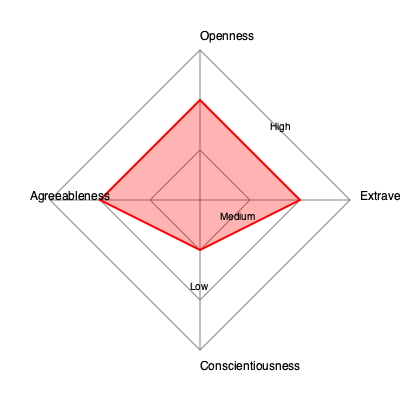Based on the radar chart depicting the distribution of personality traits among successful rehabilitation program participants, which trait appears to be the least pronounced, and what implications might this have for tailoring future interventions in rehabilitation programs? To answer this question, we need to analyze the radar chart and understand its implications:

1. Interpret the radar chart:
   - The chart shows four personality traits: Extraversion, Openness, Agreeableness, and Conscientiousness.
   - The red polygon represents the average scores for successful participants.
   - The further the polygon extends in a direction, the more pronounced that trait is.

2. Identify the least pronounced trait:
   - Agreeableness extends the least from the center, indicating it's the least pronounced trait.

3. Consider the implications for future interventions:
   - Lower Agreeableness suggests participants may be less cooperative or empathetic.
   - Interventions could focus on improving interpersonal skills and empathy.
   - Programs might incorporate more team-based activities to foster cooperation.
   - Conflict resolution training could be beneficial.
   - Individual counseling might address trust issues or social difficulties.

4. Reflect on the other traits:
   - Higher Extraversion and Openness suggest participants may respond well to social and novel experiences.
   - Moderate to high Conscientiousness indicates potential for goal-setting and self-discipline.

5. Tailor interventions:
   - Design programs that leverage strengths in Extraversion, Openness, and Conscientiousness.
   - Address the Agreeableness deficit through targeted social skill development.

By focusing on improving Agreeableness while utilizing the strengths in other traits, rehabilitation programs can be optimized for better outcomes.
Answer: Agreeableness; future interventions should focus on improving interpersonal skills, empathy, and cooperation. 